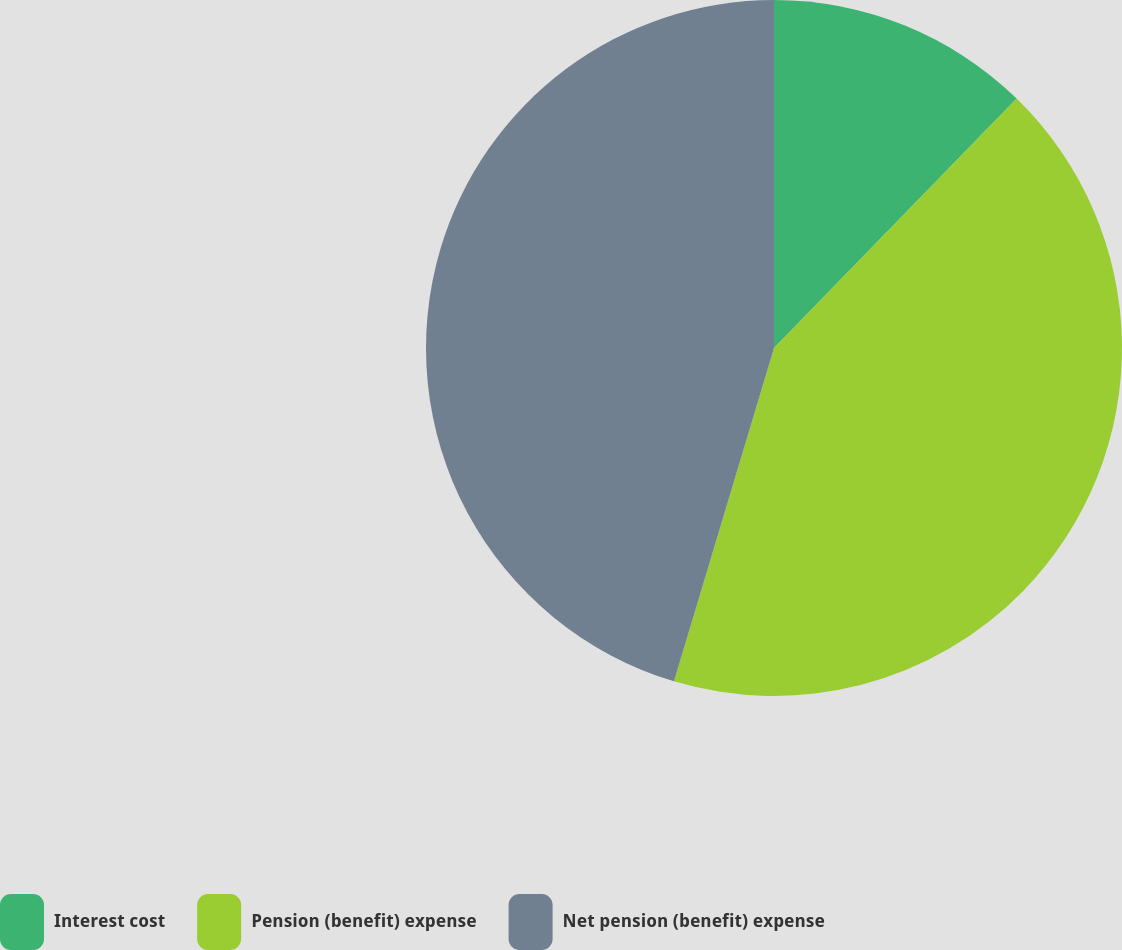Convert chart to OTSL. <chart><loc_0><loc_0><loc_500><loc_500><pie_chart><fcel>Interest cost<fcel>Pension (benefit) expense<fcel>Net pension (benefit) expense<nl><fcel>12.28%<fcel>42.36%<fcel>45.36%<nl></chart> 